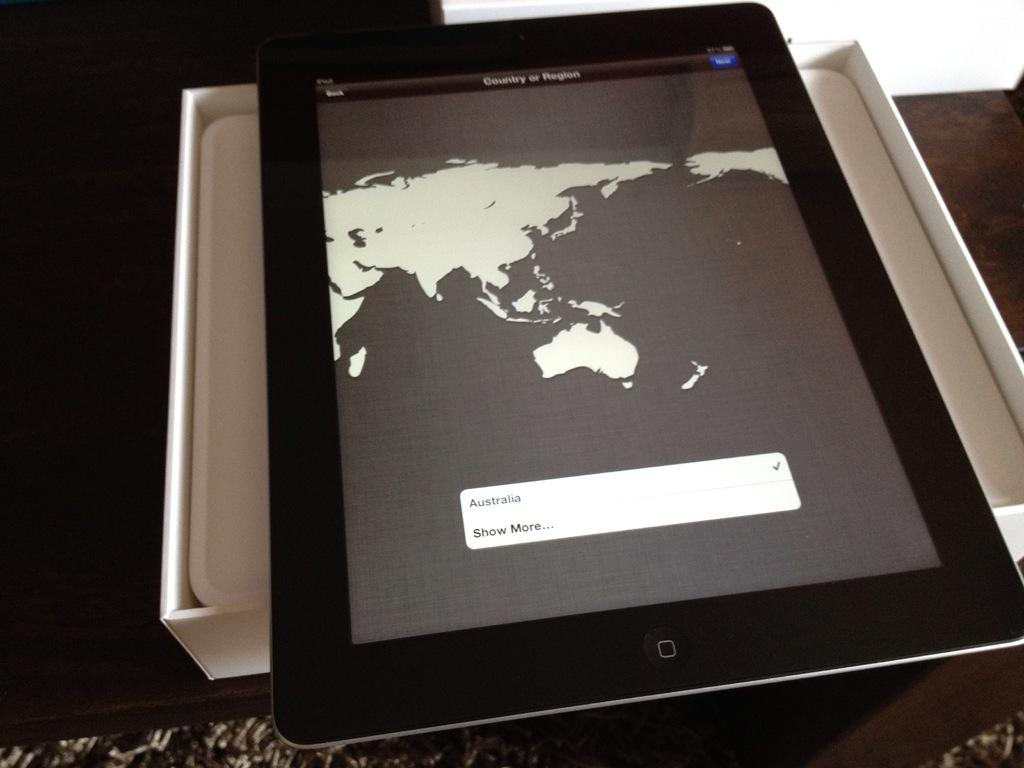What electronic device is visible in the image? There is a tablet in the image. Where is the tablet placed in the image? The tablet is kept on its box. What type of produce is being sold at the station in the image? There is no station or produce present in the image; it only features a tablet on its box. How many rings are visible on the fingers of the person holding the tablet in the image? There is no person holding the tablet in the image, so it is not possible to determine the number of rings on their fingers. 